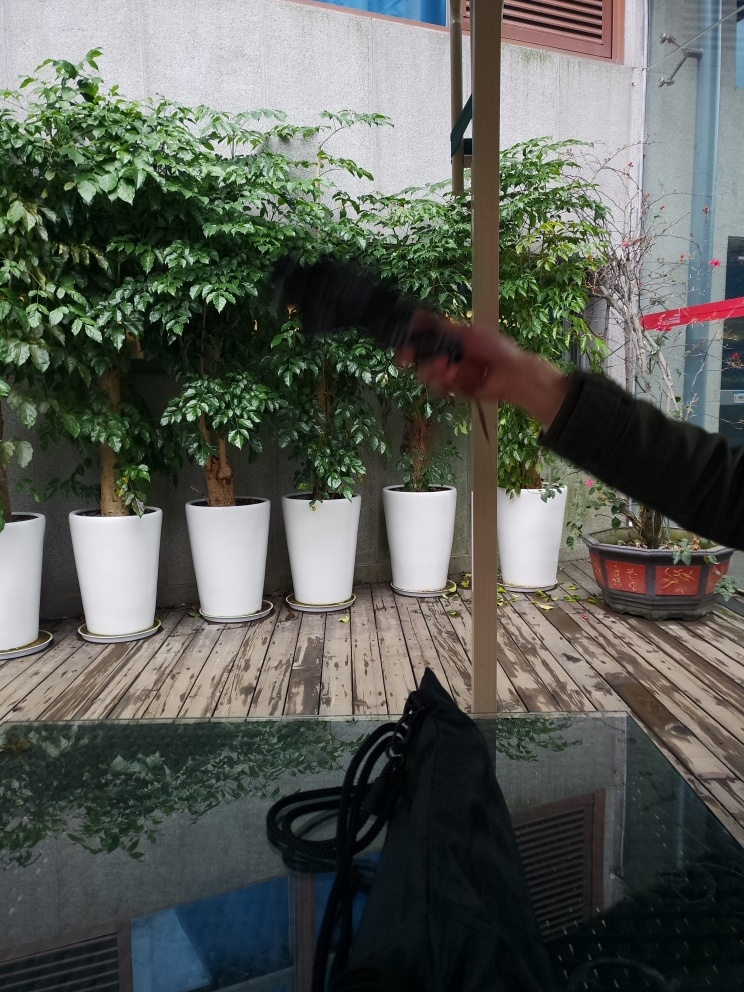Can you tell what time of day it might be based on the lighting in the image? The image appears to have been taken during the day, as indicated by the natural light that casts visible shadows and provides a bright yet diffused quality to the setting. The absence of any artificial lighting also suggests that it is not evening or night time. 